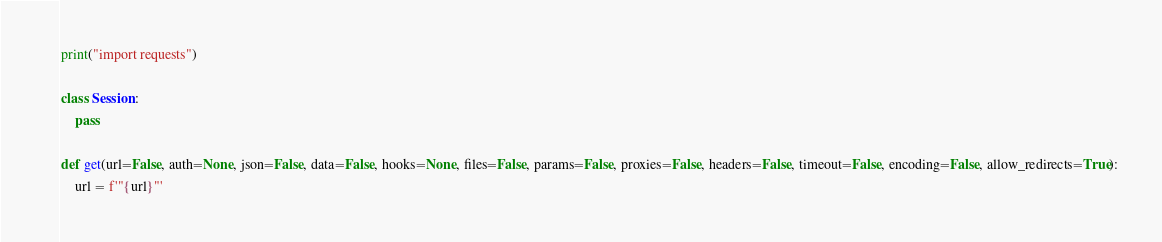<code> <loc_0><loc_0><loc_500><loc_500><_Python_>print("import requests")

class Session:
    pass

def get(url=False, auth=None, json=False, data=False, hooks=None, files=False, params=False, proxies=False, headers=False, timeout=False, encoding=False, allow_redirects=True):
    url = f'"{url}"'</code> 